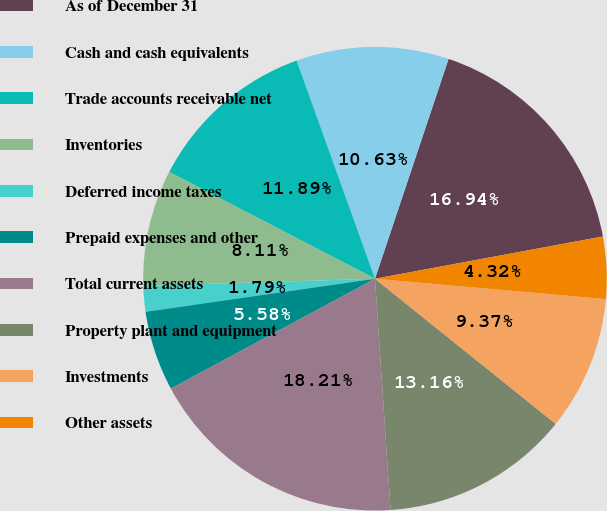Convert chart to OTSL. <chart><loc_0><loc_0><loc_500><loc_500><pie_chart><fcel>As of December 31<fcel>Cash and cash equivalents<fcel>Trade accounts receivable net<fcel>Inventories<fcel>Deferred income taxes<fcel>Prepaid expenses and other<fcel>Total current assets<fcel>Property plant and equipment<fcel>Investments<fcel>Other assets<nl><fcel>16.94%<fcel>10.63%<fcel>11.89%<fcel>8.11%<fcel>1.79%<fcel>5.58%<fcel>18.21%<fcel>13.16%<fcel>9.37%<fcel>4.32%<nl></chart> 